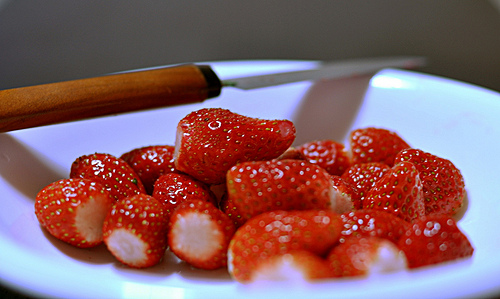<image>
Can you confirm if the knife is on the strawberries? No. The knife is not positioned on the strawberries. They may be near each other, but the knife is not supported by or resting on top of the strawberries. 